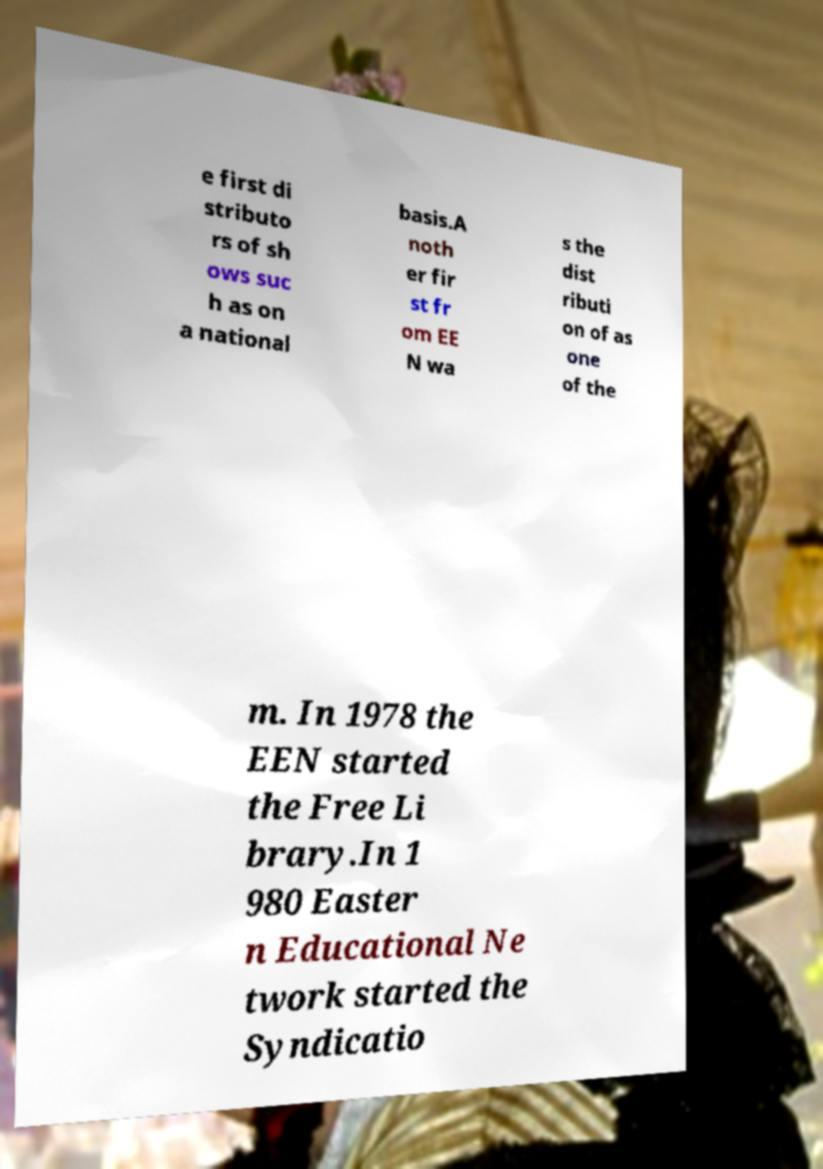I need the written content from this picture converted into text. Can you do that? e first di stributo rs of sh ows suc h as on a national basis.A noth er fir st fr om EE N wa s the dist ributi on of as one of the m. In 1978 the EEN started the Free Li brary.In 1 980 Easter n Educational Ne twork started the Syndicatio 